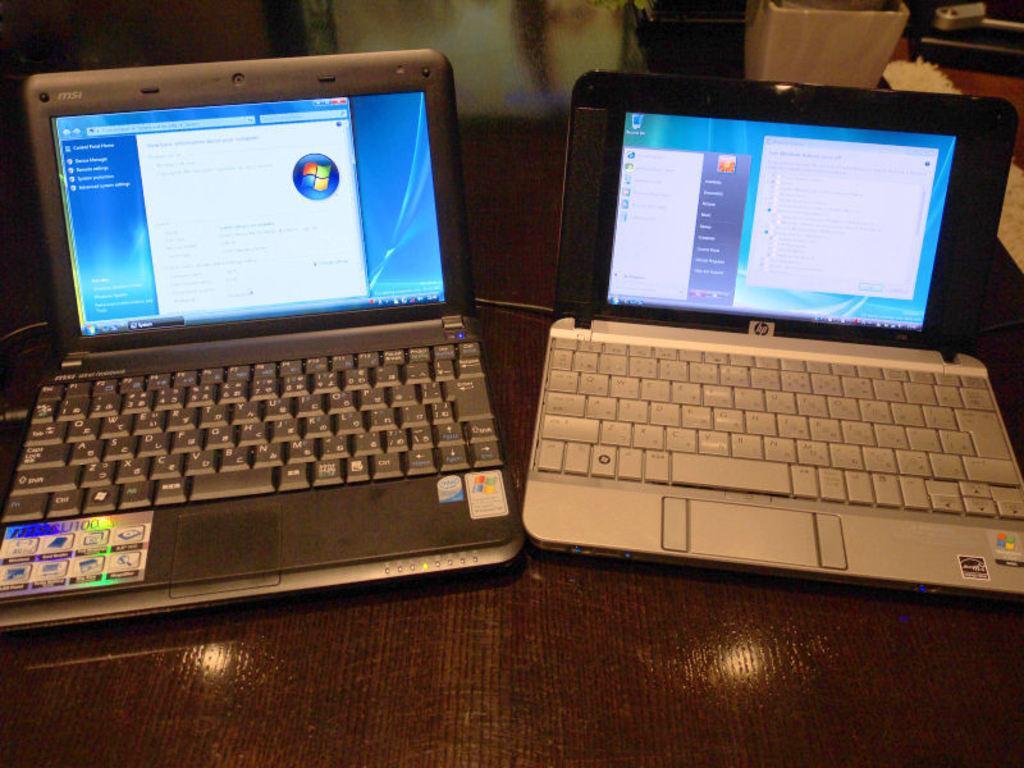In one or two sentences, can you explain what this image depicts? In this picture we can see laptops are placed on the table. 